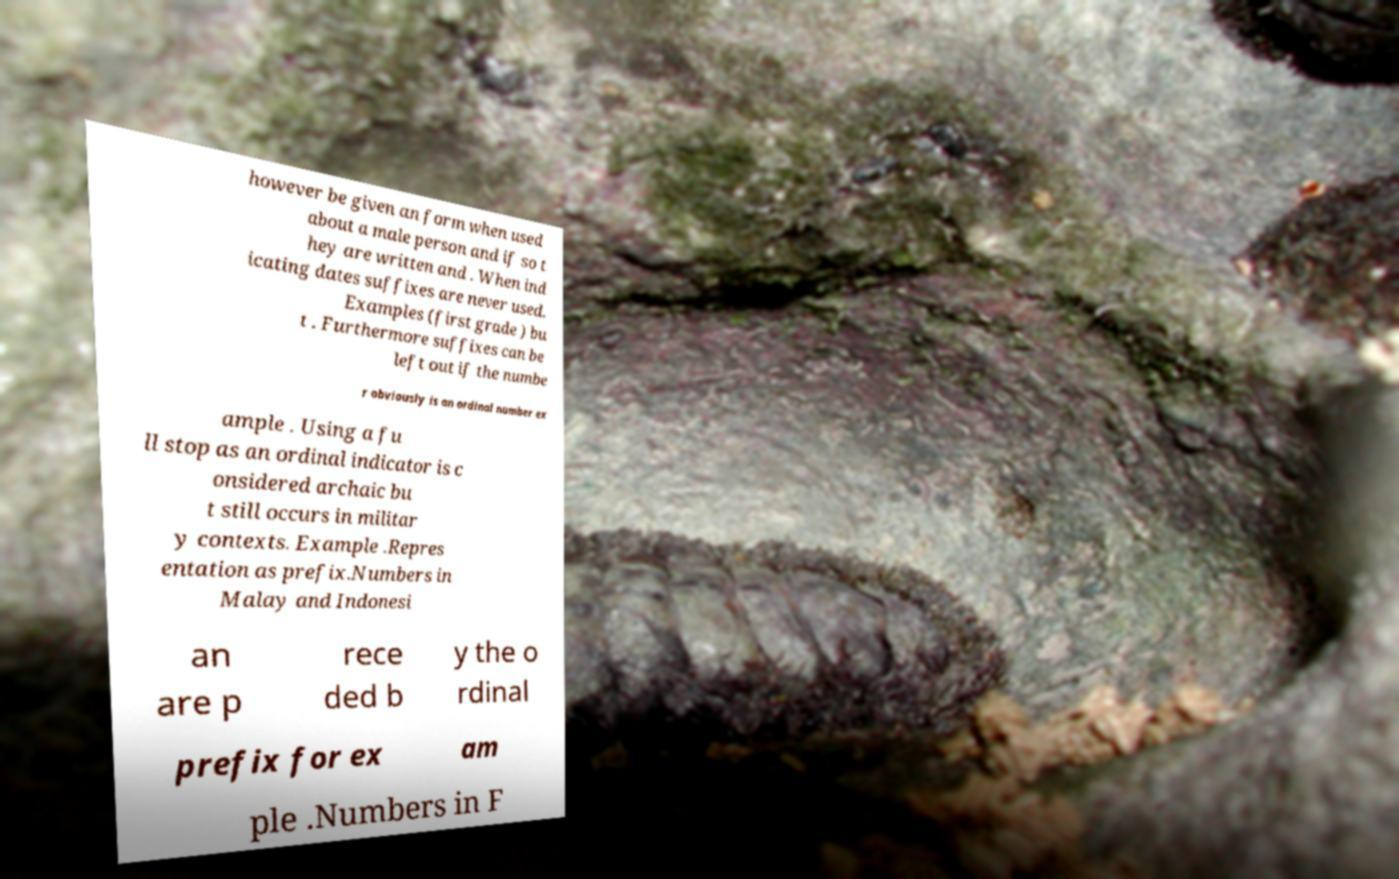Could you extract and type out the text from this image? however be given an form when used about a male person and if so t hey are written and . When ind icating dates suffixes are never used. Examples (first grade ) bu t . Furthermore suffixes can be left out if the numbe r obviously is an ordinal number ex ample . Using a fu ll stop as an ordinal indicator is c onsidered archaic bu t still occurs in militar y contexts. Example .Repres entation as prefix.Numbers in Malay and Indonesi an are p rece ded b y the o rdinal prefix for ex am ple .Numbers in F 